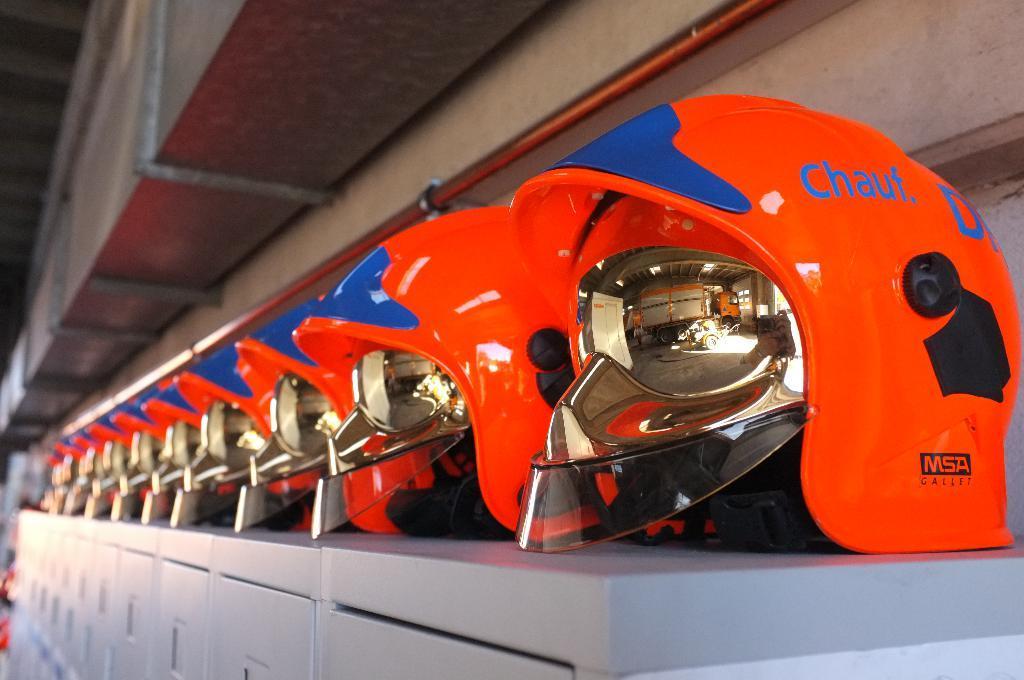Could you give a brief overview of what you see in this image? In this picture there are many red color helmet placed on the top of the silver color lockers. Above there is a air conditioner duct. 